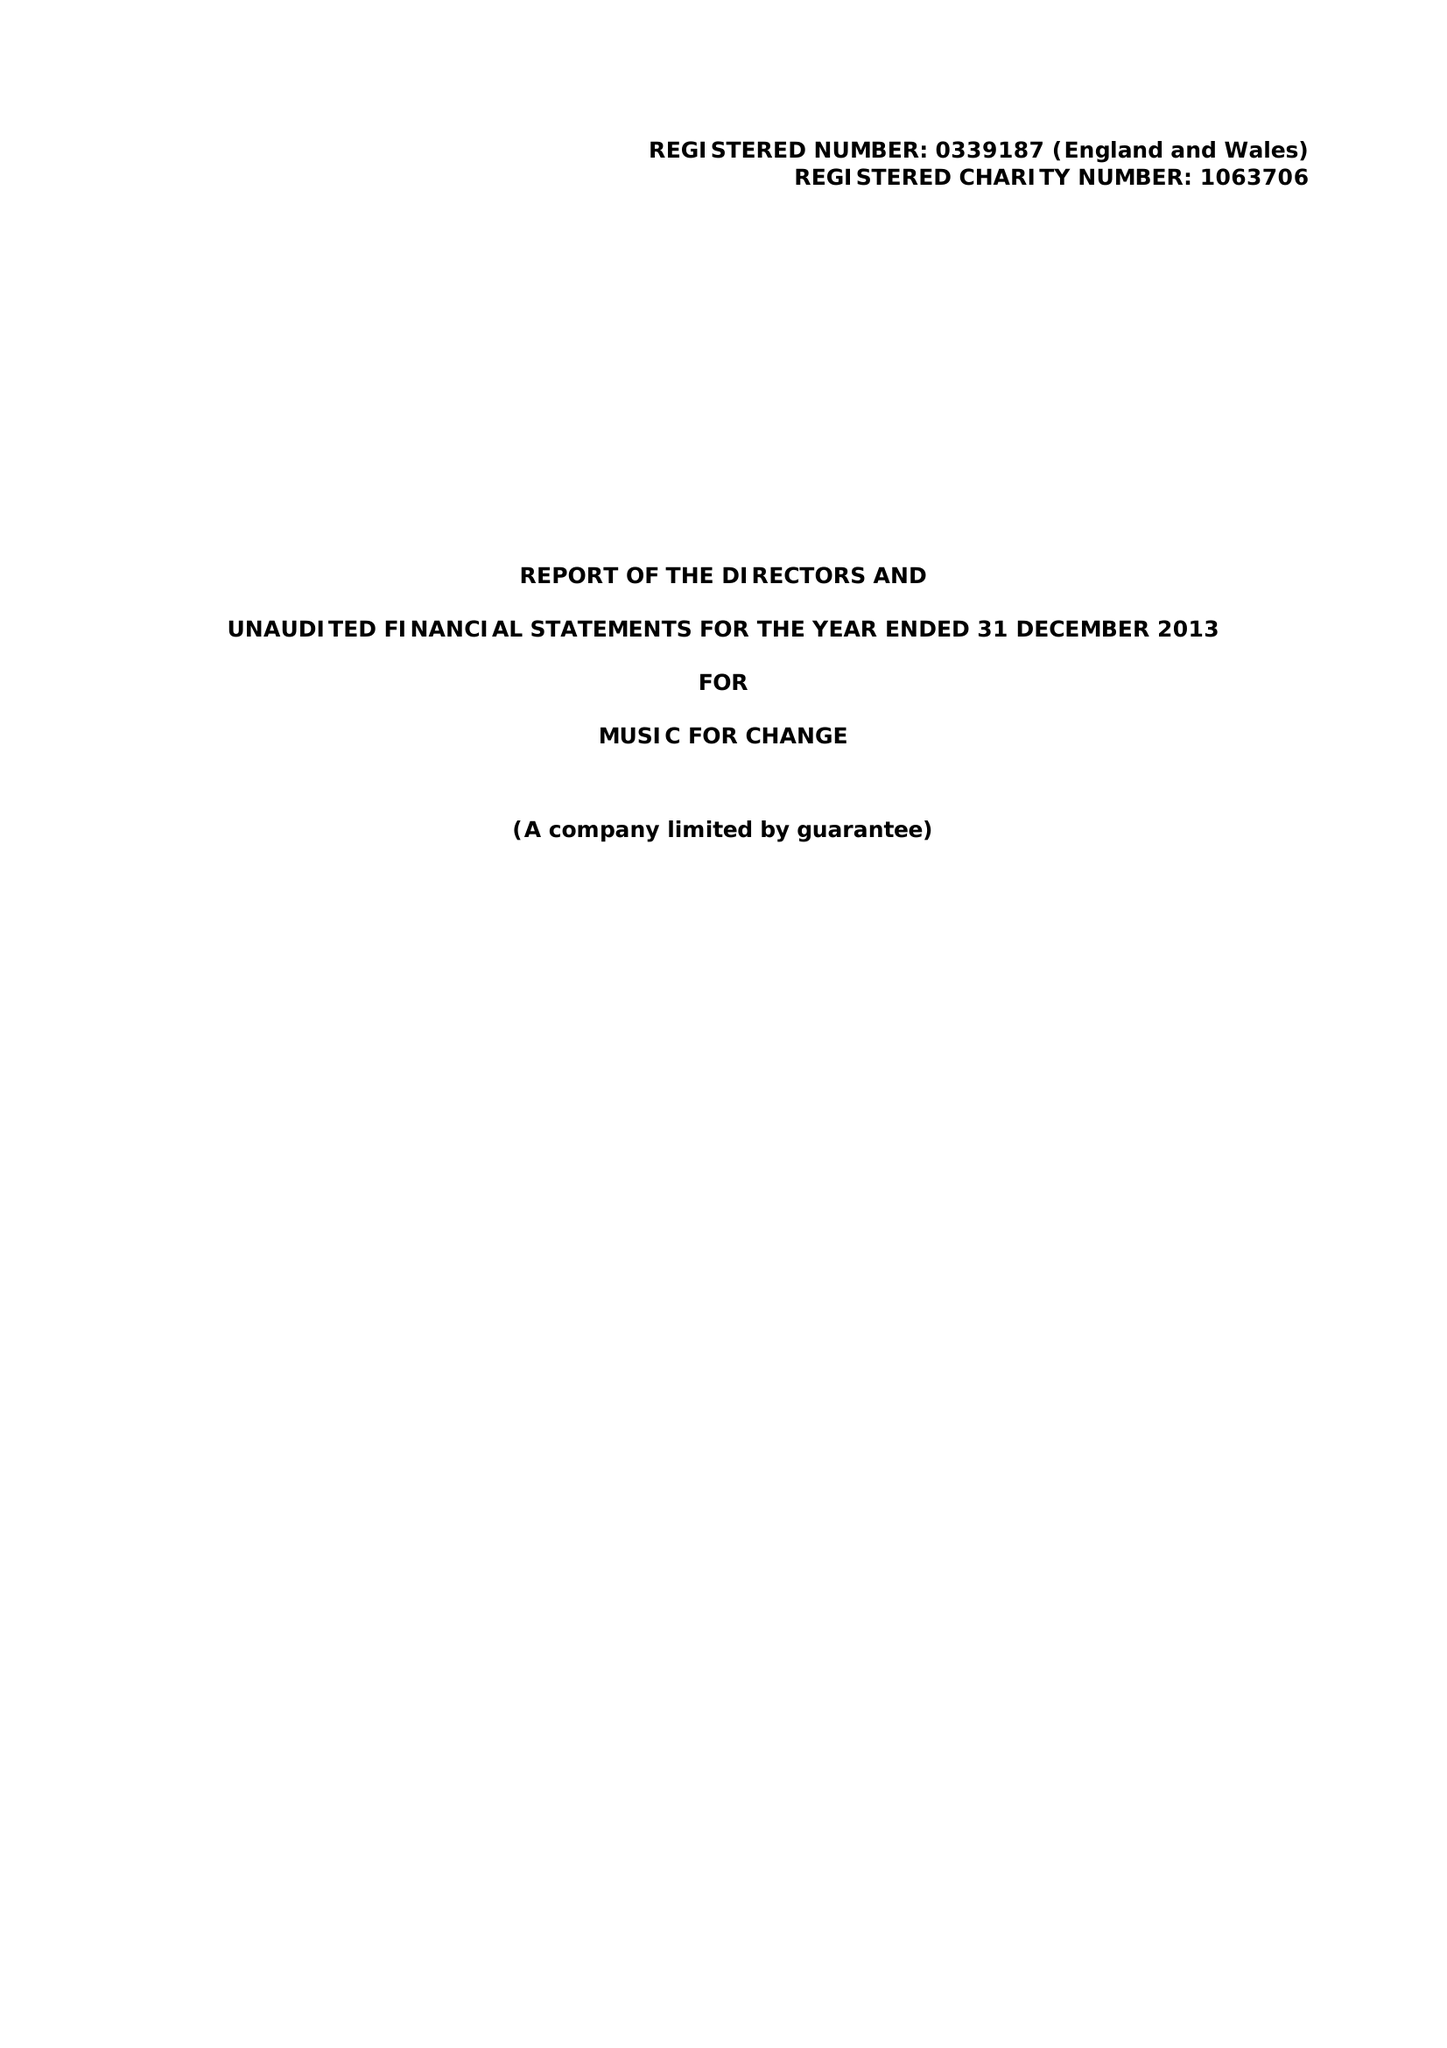What is the value for the spending_annually_in_british_pounds?
Answer the question using a single word or phrase. 142342.00 